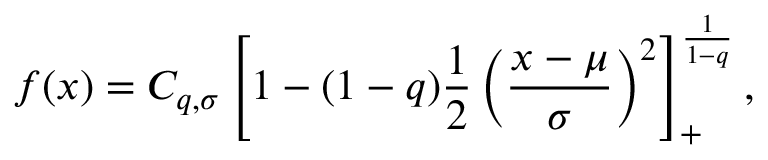<formula> <loc_0><loc_0><loc_500><loc_500>f ( x ) = C _ { q , \sigma } \left [ 1 - ( 1 - q ) \frac { 1 } { 2 } \left ( \frac { x - \mu } { \sigma } \right ) ^ { 2 } \right ] _ { + } ^ { \frac { 1 } { 1 - q } } ,</formula> 